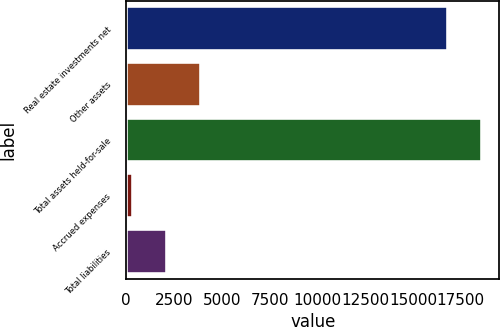Convert chart. <chart><loc_0><loc_0><loc_500><loc_500><bar_chart><fcel>Real estate investments net<fcel>Other assets<fcel>Total assets held-for-sale<fcel>Accrued expenses<fcel>Total liabilities<nl><fcel>16813<fcel>3929.4<fcel>18588.2<fcel>379<fcel>2154.2<nl></chart> 